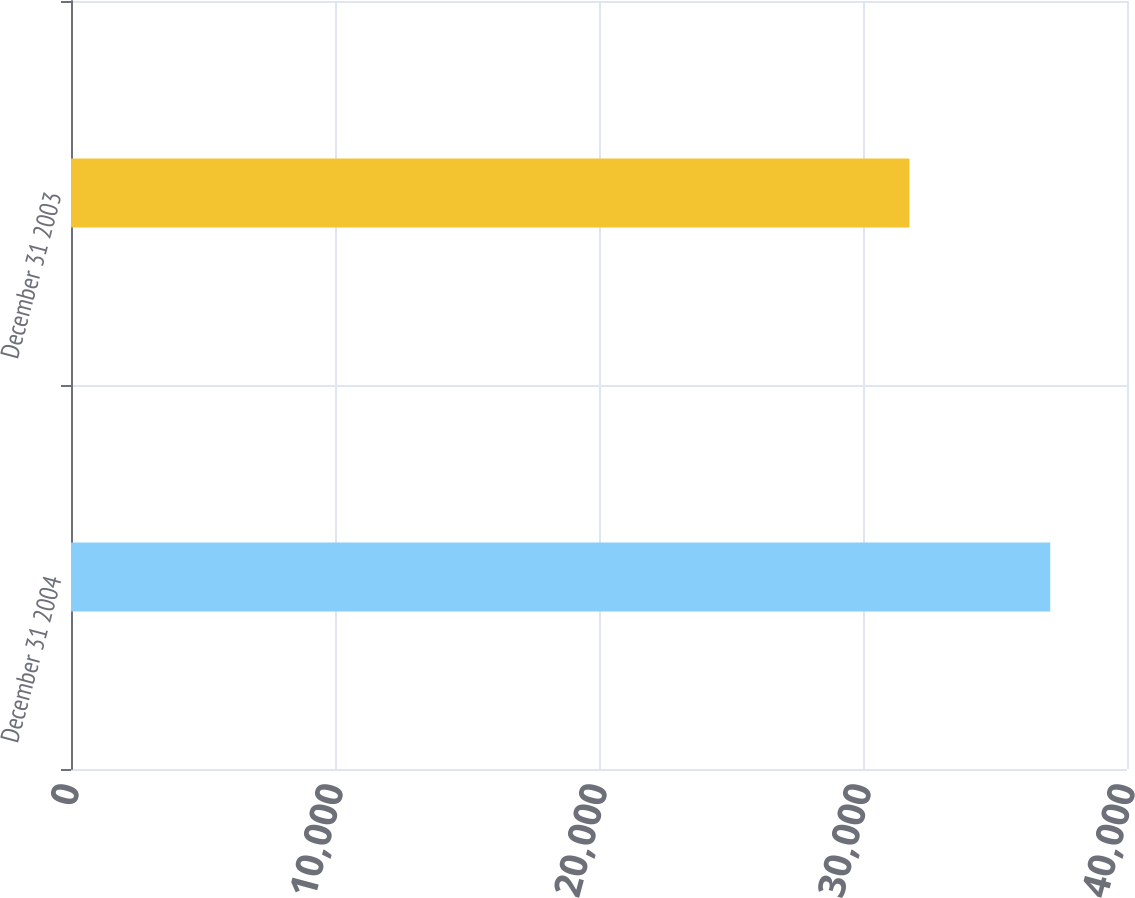<chart> <loc_0><loc_0><loc_500><loc_500><bar_chart><fcel>December 31 2004<fcel>December 31 2003<nl><fcel>37093<fcel>31759<nl></chart> 